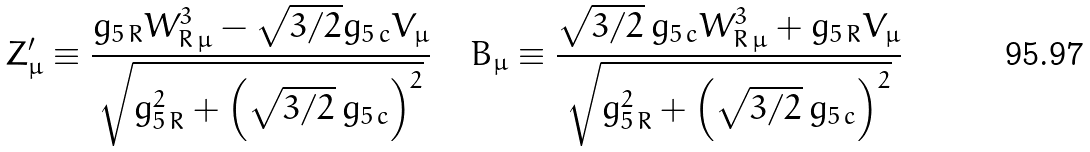<formula> <loc_0><loc_0><loc_500><loc_500>Z ^ { \prime } _ { \mu } \equiv \frac { g _ { 5 \, R } W _ { R \, \mu } ^ { 3 } - \sqrt { 3 / 2 } g _ { 5 \, c } V _ { \mu } } { \sqrt { g _ { 5 \, R } ^ { 2 } + \left ( \sqrt { 3 / 2 } \, g _ { 5 \, c } \right ) ^ { 2 } } } \quad B _ { \mu } \equiv \frac { \sqrt { 3 / 2 } \, g _ { 5 \, c } W _ { R \, \mu } ^ { 3 } + g _ { 5 \, R } V _ { \mu } } { \sqrt { g _ { 5 \, R } ^ { 2 } + \left ( \sqrt { 3 / 2 } \, g _ { 5 \, c } \right ) ^ { 2 } } }</formula> 